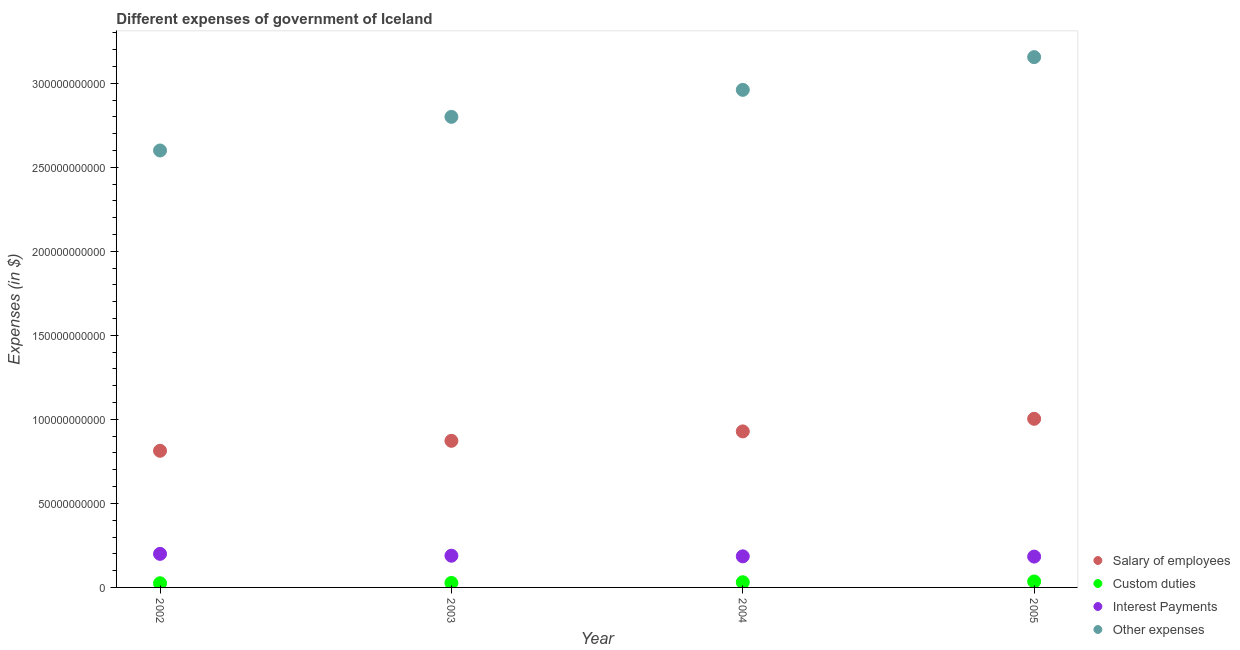How many different coloured dotlines are there?
Offer a terse response. 4. What is the amount spent on interest payments in 2002?
Offer a terse response. 2.00e+1. Across all years, what is the maximum amount spent on other expenses?
Your answer should be very brief. 3.16e+11. Across all years, what is the minimum amount spent on other expenses?
Ensure brevity in your answer.  2.60e+11. In which year was the amount spent on other expenses maximum?
Your response must be concise. 2005. In which year was the amount spent on salary of employees minimum?
Offer a terse response. 2002. What is the total amount spent on salary of employees in the graph?
Your answer should be compact. 3.62e+11. What is the difference between the amount spent on salary of employees in 2002 and that in 2005?
Your response must be concise. -1.90e+1. What is the difference between the amount spent on interest payments in 2002 and the amount spent on other expenses in 2004?
Offer a very short reply. -2.76e+11. What is the average amount spent on salary of employees per year?
Your answer should be compact. 9.04e+1. In the year 2002, what is the difference between the amount spent on salary of employees and amount spent on custom duties?
Provide a succinct answer. 7.88e+1. In how many years, is the amount spent on interest payments greater than 30000000000 $?
Make the answer very short. 0. What is the ratio of the amount spent on interest payments in 2002 to that in 2003?
Ensure brevity in your answer.  1.06. What is the difference between the highest and the second highest amount spent on salary of employees?
Your answer should be compact. 7.50e+09. What is the difference between the highest and the lowest amount spent on interest payments?
Offer a very short reply. 1.62e+09. Is the sum of the amount spent on salary of employees in 2003 and 2004 greater than the maximum amount spent on custom duties across all years?
Your response must be concise. Yes. Is it the case that in every year, the sum of the amount spent on salary of employees and amount spent on custom duties is greater than the amount spent on interest payments?
Ensure brevity in your answer.  Yes. How many dotlines are there?
Your response must be concise. 4. What is the difference between two consecutive major ticks on the Y-axis?
Offer a terse response. 5.00e+1. Does the graph contain grids?
Provide a short and direct response. No. How many legend labels are there?
Your response must be concise. 4. What is the title of the graph?
Keep it short and to the point. Different expenses of government of Iceland. Does "Secondary vocational education" appear as one of the legend labels in the graph?
Make the answer very short. No. What is the label or title of the Y-axis?
Your answer should be compact. Expenses (in $). What is the Expenses (in $) of Salary of employees in 2002?
Your answer should be very brief. 8.13e+1. What is the Expenses (in $) in Custom duties in 2002?
Provide a succinct answer. 2.47e+09. What is the Expenses (in $) in Interest Payments in 2002?
Keep it short and to the point. 2.00e+1. What is the Expenses (in $) in Other expenses in 2002?
Provide a short and direct response. 2.60e+11. What is the Expenses (in $) in Salary of employees in 2003?
Offer a very short reply. 8.72e+1. What is the Expenses (in $) in Custom duties in 2003?
Your answer should be compact. 2.68e+09. What is the Expenses (in $) of Interest Payments in 2003?
Your response must be concise. 1.89e+1. What is the Expenses (in $) in Other expenses in 2003?
Make the answer very short. 2.80e+11. What is the Expenses (in $) of Salary of employees in 2004?
Your answer should be compact. 9.28e+1. What is the Expenses (in $) of Custom duties in 2004?
Your answer should be compact. 3.09e+09. What is the Expenses (in $) in Interest Payments in 2004?
Provide a short and direct response. 1.85e+1. What is the Expenses (in $) in Other expenses in 2004?
Provide a succinct answer. 2.96e+11. What is the Expenses (in $) in Salary of employees in 2005?
Provide a succinct answer. 1.00e+11. What is the Expenses (in $) of Custom duties in 2005?
Your response must be concise. 3.54e+09. What is the Expenses (in $) in Interest Payments in 2005?
Make the answer very short. 1.84e+1. What is the Expenses (in $) in Other expenses in 2005?
Your answer should be compact. 3.16e+11. Across all years, what is the maximum Expenses (in $) of Salary of employees?
Offer a terse response. 1.00e+11. Across all years, what is the maximum Expenses (in $) of Custom duties?
Provide a succinct answer. 3.54e+09. Across all years, what is the maximum Expenses (in $) in Interest Payments?
Provide a succinct answer. 2.00e+1. Across all years, what is the maximum Expenses (in $) in Other expenses?
Provide a short and direct response. 3.16e+11. Across all years, what is the minimum Expenses (in $) in Salary of employees?
Offer a terse response. 8.13e+1. Across all years, what is the minimum Expenses (in $) of Custom duties?
Offer a terse response. 2.47e+09. Across all years, what is the minimum Expenses (in $) of Interest Payments?
Make the answer very short. 1.84e+1. Across all years, what is the minimum Expenses (in $) in Other expenses?
Make the answer very short. 2.60e+11. What is the total Expenses (in $) in Salary of employees in the graph?
Give a very brief answer. 3.62e+11. What is the total Expenses (in $) of Custom duties in the graph?
Offer a very short reply. 1.18e+1. What is the total Expenses (in $) in Interest Payments in the graph?
Make the answer very short. 7.57e+1. What is the total Expenses (in $) of Other expenses in the graph?
Offer a very short reply. 1.15e+12. What is the difference between the Expenses (in $) in Salary of employees in 2002 and that in 2003?
Provide a succinct answer. -5.93e+09. What is the difference between the Expenses (in $) of Custom duties in 2002 and that in 2003?
Offer a terse response. -2.06e+08. What is the difference between the Expenses (in $) in Interest Payments in 2002 and that in 2003?
Provide a succinct answer. 1.10e+09. What is the difference between the Expenses (in $) of Other expenses in 2002 and that in 2003?
Your answer should be very brief. -2.00e+1. What is the difference between the Expenses (in $) of Salary of employees in 2002 and that in 2004?
Ensure brevity in your answer.  -1.15e+1. What is the difference between the Expenses (in $) in Custom duties in 2002 and that in 2004?
Your response must be concise. -6.12e+08. What is the difference between the Expenses (in $) in Interest Payments in 2002 and that in 2004?
Ensure brevity in your answer.  1.46e+09. What is the difference between the Expenses (in $) in Other expenses in 2002 and that in 2004?
Provide a succinct answer. -3.61e+1. What is the difference between the Expenses (in $) of Salary of employees in 2002 and that in 2005?
Give a very brief answer. -1.90e+1. What is the difference between the Expenses (in $) of Custom duties in 2002 and that in 2005?
Ensure brevity in your answer.  -1.06e+09. What is the difference between the Expenses (in $) of Interest Payments in 2002 and that in 2005?
Make the answer very short. 1.62e+09. What is the difference between the Expenses (in $) in Other expenses in 2002 and that in 2005?
Provide a short and direct response. -5.55e+1. What is the difference between the Expenses (in $) in Salary of employees in 2003 and that in 2004?
Keep it short and to the point. -5.61e+09. What is the difference between the Expenses (in $) of Custom duties in 2003 and that in 2004?
Your answer should be very brief. -4.06e+08. What is the difference between the Expenses (in $) of Interest Payments in 2003 and that in 2004?
Offer a very short reply. 3.63e+08. What is the difference between the Expenses (in $) in Other expenses in 2003 and that in 2004?
Offer a terse response. -1.61e+1. What is the difference between the Expenses (in $) in Salary of employees in 2003 and that in 2005?
Offer a very short reply. -1.31e+1. What is the difference between the Expenses (in $) of Custom duties in 2003 and that in 2005?
Ensure brevity in your answer.  -8.59e+08. What is the difference between the Expenses (in $) in Interest Payments in 2003 and that in 2005?
Keep it short and to the point. 5.17e+08. What is the difference between the Expenses (in $) in Other expenses in 2003 and that in 2005?
Offer a very short reply. -3.55e+1. What is the difference between the Expenses (in $) in Salary of employees in 2004 and that in 2005?
Make the answer very short. -7.50e+09. What is the difference between the Expenses (in $) in Custom duties in 2004 and that in 2005?
Ensure brevity in your answer.  -4.53e+08. What is the difference between the Expenses (in $) in Interest Payments in 2004 and that in 2005?
Provide a succinct answer. 1.53e+08. What is the difference between the Expenses (in $) in Other expenses in 2004 and that in 2005?
Ensure brevity in your answer.  -1.95e+1. What is the difference between the Expenses (in $) of Salary of employees in 2002 and the Expenses (in $) of Custom duties in 2003?
Offer a terse response. 7.86e+1. What is the difference between the Expenses (in $) of Salary of employees in 2002 and the Expenses (in $) of Interest Payments in 2003?
Ensure brevity in your answer.  6.24e+1. What is the difference between the Expenses (in $) of Salary of employees in 2002 and the Expenses (in $) of Other expenses in 2003?
Provide a short and direct response. -1.99e+11. What is the difference between the Expenses (in $) of Custom duties in 2002 and the Expenses (in $) of Interest Payments in 2003?
Offer a very short reply. -1.64e+1. What is the difference between the Expenses (in $) of Custom duties in 2002 and the Expenses (in $) of Other expenses in 2003?
Your answer should be compact. -2.78e+11. What is the difference between the Expenses (in $) in Interest Payments in 2002 and the Expenses (in $) in Other expenses in 2003?
Offer a terse response. -2.60e+11. What is the difference between the Expenses (in $) in Salary of employees in 2002 and the Expenses (in $) in Custom duties in 2004?
Give a very brief answer. 7.82e+1. What is the difference between the Expenses (in $) of Salary of employees in 2002 and the Expenses (in $) of Interest Payments in 2004?
Your response must be concise. 6.28e+1. What is the difference between the Expenses (in $) of Salary of employees in 2002 and the Expenses (in $) of Other expenses in 2004?
Ensure brevity in your answer.  -2.15e+11. What is the difference between the Expenses (in $) in Custom duties in 2002 and the Expenses (in $) in Interest Payments in 2004?
Offer a very short reply. -1.60e+1. What is the difference between the Expenses (in $) of Custom duties in 2002 and the Expenses (in $) of Other expenses in 2004?
Your response must be concise. -2.94e+11. What is the difference between the Expenses (in $) of Interest Payments in 2002 and the Expenses (in $) of Other expenses in 2004?
Make the answer very short. -2.76e+11. What is the difference between the Expenses (in $) in Salary of employees in 2002 and the Expenses (in $) in Custom duties in 2005?
Your answer should be compact. 7.78e+1. What is the difference between the Expenses (in $) of Salary of employees in 2002 and the Expenses (in $) of Interest Payments in 2005?
Provide a short and direct response. 6.30e+1. What is the difference between the Expenses (in $) in Salary of employees in 2002 and the Expenses (in $) in Other expenses in 2005?
Ensure brevity in your answer.  -2.34e+11. What is the difference between the Expenses (in $) of Custom duties in 2002 and the Expenses (in $) of Interest Payments in 2005?
Offer a very short reply. -1.59e+1. What is the difference between the Expenses (in $) of Custom duties in 2002 and the Expenses (in $) of Other expenses in 2005?
Ensure brevity in your answer.  -3.13e+11. What is the difference between the Expenses (in $) of Interest Payments in 2002 and the Expenses (in $) of Other expenses in 2005?
Offer a very short reply. -2.96e+11. What is the difference between the Expenses (in $) in Salary of employees in 2003 and the Expenses (in $) in Custom duties in 2004?
Your answer should be compact. 8.42e+1. What is the difference between the Expenses (in $) in Salary of employees in 2003 and the Expenses (in $) in Interest Payments in 2004?
Offer a terse response. 6.87e+1. What is the difference between the Expenses (in $) of Salary of employees in 2003 and the Expenses (in $) of Other expenses in 2004?
Give a very brief answer. -2.09e+11. What is the difference between the Expenses (in $) in Custom duties in 2003 and the Expenses (in $) in Interest Payments in 2004?
Offer a very short reply. -1.58e+1. What is the difference between the Expenses (in $) of Custom duties in 2003 and the Expenses (in $) of Other expenses in 2004?
Ensure brevity in your answer.  -2.93e+11. What is the difference between the Expenses (in $) of Interest Payments in 2003 and the Expenses (in $) of Other expenses in 2004?
Your answer should be very brief. -2.77e+11. What is the difference between the Expenses (in $) in Salary of employees in 2003 and the Expenses (in $) in Custom duties in 2005?
Your answer should be very brief. 8.37e+1. What is the difference between the Expenses (in $) in Salary of employees in 2003 and the Expenses (in $) in Interest Payments in 2005?
Give a very brief answer. 6.89e+1. What is the difference between the Expenses (in $) of Salary of employees in 2003 and the Expenses (in $) of Other expenses in 2005?
Offer a terse response. -2.28e+11. What is the difference between the Expenses (in $) of Custom duties in 2003 and the Expenses (in $) of Interest Payments in 2005?
Your response must be concise. -1.57e+1. What is the difference between the Expenses (in $) in Custom duties in 2003 and the Expenses (in $) in Other expenses in 2005?
Offer a very short reply. -3.13e+11. What is the difference between the Expenses (in $) in Interest Payments in 2003 and the Expenses (in $) in Other expenses in 2005?
Offer a very short reply. -2.97e+11. What is the difference between the Expenses (in $) of Salary of employees in 2004 and the Expenses (in $) of Custom duties in 2005?
Your answer should be compact. 8.93e+1. What is the difference between the Expenses (in $) of Salary of employees in 2004 and the Expenses (in $) of Interest Payments in 2005?
Give a very brief answer. 7.45e+1. What is the difference between the Expenses (in $) of Salary of employees in 2004 and the Expenses (in $) of Other expenses in 2005?
Your answer should be very brief. -2.23e+11. What is the difference between the Expenses (in $) in Custom duties in 2004 and the Expenses (in $) in Interest Payments in 2005?
Keep it short and to the point. -1.53e+1. What is the difference between the Expenses (in $) in Custom duties in 2004 and the Expenses (in $) in Other expenses in 2005?
Keep it short and to the point. -3.12e+11. What is the difference between the Expenses (in $) in Interest Payments in 2004 and the Expenses (in $) in Other expenses in 2005?
Your answer should be very brief. -2.97e+11. What is the average Expenses (in $) of Salary of employees per year?
Keep it short and to the point. 9.04e+1. What is the average Expenses (in $) of Custom duties per year?
Your answer should be very brief. 2.94e+09. What is the average Expenses (in $) in Interest Payments per year?
Provide a short and direct response. 1.89e+1. What is the average Expenses (in $) of Other expenses per year?
Offer a terse response. 2.88e+11. In the year 2002, what is the difference between the Expenses (in $) in Salary of employees and Expenses (in $) in Custom duties?
Give a very brief answer. 7.88e+1. In the year 2002, what is the difference between the Expenses (in $) in Salary of employees and Expenses (in $) in Interest Payments?
Provide a succinct answer. 6.13e+1. In the year 2002, what is the difference between the Expenses (in $) in Salary of employees and Expenses (in $) in Other expenses?
Provide a short and direct response. -1.79e+11. In the year 2002, what is the difference between the Expenses (in $) in Custom duties and Expenses (in $) in Interest Payments?
Offer a very short reply. -1.75e+1. In the year 2002, what is the difference between the Expenses (in $) in Custom duties and Expenses (in $) in Other expenses?
Make the answer very short. -2.58e+11. In the year 2002, what is the difference between the Expenses (in $) of Interest Payments and Expenses (in $) of Other expenses?
Keep it short and to the point. -2.40e+11. In the year 2003, what is the difference between the Expenses (in $) in Salary of employees and Expenses (in $) in Custom duties?
Provide a short and direct response. 8.46e+1. In the year 2003, what is the difference between the Expenses (in $) in Salary of employees and Expenses (in $) in Interest Payments?
Make the answer very short. 6.84e+1. In the year 2003, what is the difference between the Expenses (in $) in Salary of employees and Expenses (in $) in Other expenses?
Make the answer very short. -1.93e+11. In the year 2003, what is the difference between the Expenses (in $) in Custom duties and Expenses (in $) in Interest Payments?
Offer a terse response. -1.62e+1. In the year 2003, what is the difference between the Expenses (in $) of Custom duties and Expenses (in $) of Other expenses?
Provide a succinct answer. -2.77e+11. In the year 2003, what is the difference between the Expenses (in $) in Interest Payments and Expenses (in $) in Other expenses?
Your response must be concise. -2.61e+11. In the year 2004, what is the difference between the Expenses (in $) of Salary of employees and Expenses (in $) of Custom duties?
Your response must be concise. 8.98e+1. In the year 2004, what is the difference between the Expenses (in $) of Salary of employees and Expenses (in $) of Interest Payments?
Keep it short and to the point. 7.43e+1. In the year 2004, what is the difference between the Expenses (in $) in Salary of employees and Expenses (in $) in Other expenses?
Your answer should be very brief. -2.03e+11. In the year 2004, what is the difference between the Expenses (in $) in Custom duties and Expenses (in $) in Interest Payments?
Give a very brief answer. -1.54e+1. In the year 2004, what is the difference between the Expenses (in $) in Custom duties and Expenses (in $) in Other expenses?
Offer a terse response. -2.93e+11. In the year 2004, what is the difference between the Expenses (in $) in Interest Payments and Expenses (in $) in Other expenses?
Your answer should be very brief. -2.78e+11. In the year 2005, what is the difference between the Expenses (in $) in Salary of employees and Expenses (in $) in Custom duties?
Offer a terse response. 9.68e+1. In the year 2005, what is the difference between the Expenses (in $) of Salary of employees and Expenses (in $) of Interest Payments?
Keep it short and to the point. 8.20e+1. In the year 2005, what is the difference between the Expenses (in $) in Salary of employees and Expenses (in $) in Other expenses?
Offer a terse response. -2.15e+11. In the year 2005, what is the difference between the Expenses (in $) of Custom duties and Expenses (in $) of Interest Payments?
Make the answer very short. -1.48e+1. In the year 2005, what is the difference between the Expenses (in $) of Custom duties and Expenses (in $) of Other expenses?
Keep it short and to the point. -3.12e+11. In the year 2005, what is the difference between the Expenses (in $) in Interest Payments and Expenses (in $) in Other expenses?
Ensure brevity in your answer.  -2.97e+11. What is the ratio of the Expenses (in $) in Salary of employees in 2002 to that in 2003?
Your answer should be very brief. 0.93. What is the ratio of the Expenses (in $) of Custom duties in 2002 to that in 2003?
Provide a short and direct response. 0.92. What is the ratio of the Expenses (in $) of Interest Payments in 2002 to that in 2003?
Provide a short and direct response. 1.06. What is the ratio of the Expenses (in $) in Salary of employees in 2002 to that in 2004?
Your response must be concise. 0.88. What is the ratio of the Expenses (in $) of Custom duties in 2002 to that in 2004?
Provide a succinct answer. 0.8. What is the ratio of the Expenses (in $) in Interest Payments in 2002 to that in 2004?
Provide a short and direct response. 1.08. What is the ratio of the Expenses (in $) of Other expenses in 2002 to that in 2004?
Make the answer very short. 0.88. What is the ratio of the Expenses (in $) of Salary of employees in 2002 to that in 2005?
Make the answer very short. 0.81. What is the ratio of the Expenses (in $) of Custom duties in 2002 to that in 2005?
Offer a very short reply. 0.7. What is the ratio of the Expenses (in $) in Interest Payments in 2002 to that in 2005?
Give a very brief answer. 1.09. What is the ratio of the Expenses (in $) in Other expenses in 2002 to that in 2005?
Offer a very short reply. 0.82. What is the ratio of the Expenses (in $) of Salary of employees in 2003 to that in 2004?
Provide a succinct answer. 0.94. What is the ratio of the Expenses (in $) of Custom duties in 2003 to that in 2004?
Provide a short and direct response. 0.87. What is the ratio of the Expenses (in $) in Interest Payments in 2003 to that in 2004?
Keep it short and to the point. 1.02. What is the ratio of the Expenses (in $) in Other expenses in 2003 to that in 2004?
Make the answer very short. 0.95. What is the ratio of the Expenses (in $) of Salary of employees in 2003 to that in 2005?
Keep it short and to the point. 0.87. What is the ratio of the Expenses (in $) in Custom duties in 2003 to that in 2005?
Your answer should be compact. 0.76. What is the ratio of the Expenses (in $) of Interest Payments in 2003 to that in 2005?
Provide a succinct answer. 1.03. What is the ratio of the Expenses (in $) in Other expenses in 2003 to that in 2005?
Provide a succinct answer. 0.89. What is the ratio of the Expenses (in $) in Salary of employees in 2004 to that in 2005?
Offer a very short reply. 0.93. What is the ratio of the Expenses (in $) in Custom duties in 2004 to that in 2005?
Provide a succinct answer. 0.87. What is the ratio of the Expenses (in $) of Interest Payments in 2004 to that in 2005?
Ensure brevity in your answer.  1.01. What is the ratio of the Expenses (in $) in Other expenses in 2004 to that in 2005?
Your answer should be very brief. 0.94. What is the difference between the highest and the second highest Expenses (in $) in Salary of employees?
Provide a succinct answer. 7.50e+09. What is the difference between the highest and the second highest Expenses (in $) in Custom duties?
Offer a terse response. 4.53e+08. What is the difference between the highest and the second highest Expenses (in $) of Interest Payments?
Keep it short and to the point. 1.10e+09. What is the difference between the highest and the second highest Expenses (in $) in Other expenses?
Ensure brevity in your answer.  1.95e+1. What is the difference between the highest and the lowest Expenses (in $) in Salary of employees?
Give a very brief answer. 1.90e+1. What is the difference between the highest and the lowest Expenses (in $) of Custom duties?
Ensure brevity in your answer.  1.06e+09. What is the difference between the highest and the lowest Expenses (in $) of Interest Payments?
Your answer should be compact. 1.62e+09. What is the difference between the highest and the lowest Expenses (in $) in Other expenses?
Give a very brief answer. 5.55e+1. 